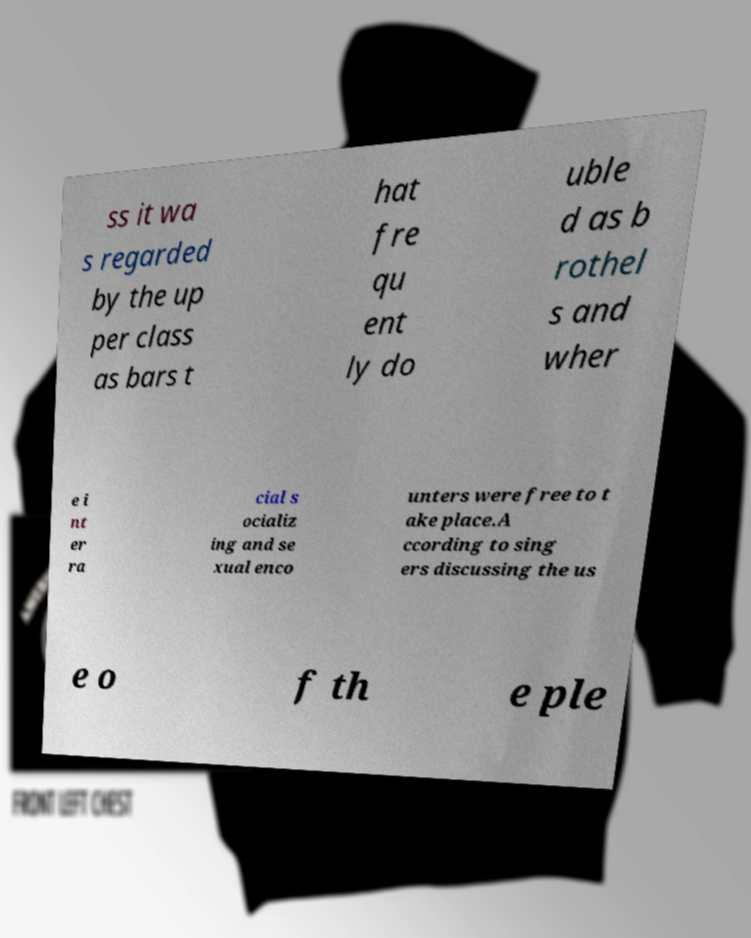Could you extract and type out the text from this image? ss it wa s regarded by the up per class as bars t hat fre qu ent ly do uble d as b rothel s and wher e i nt er ra cial s ocializ ing and se xual enco unters were free to t ake place.A ccording to sing ers discussing the us e o f th e ple 